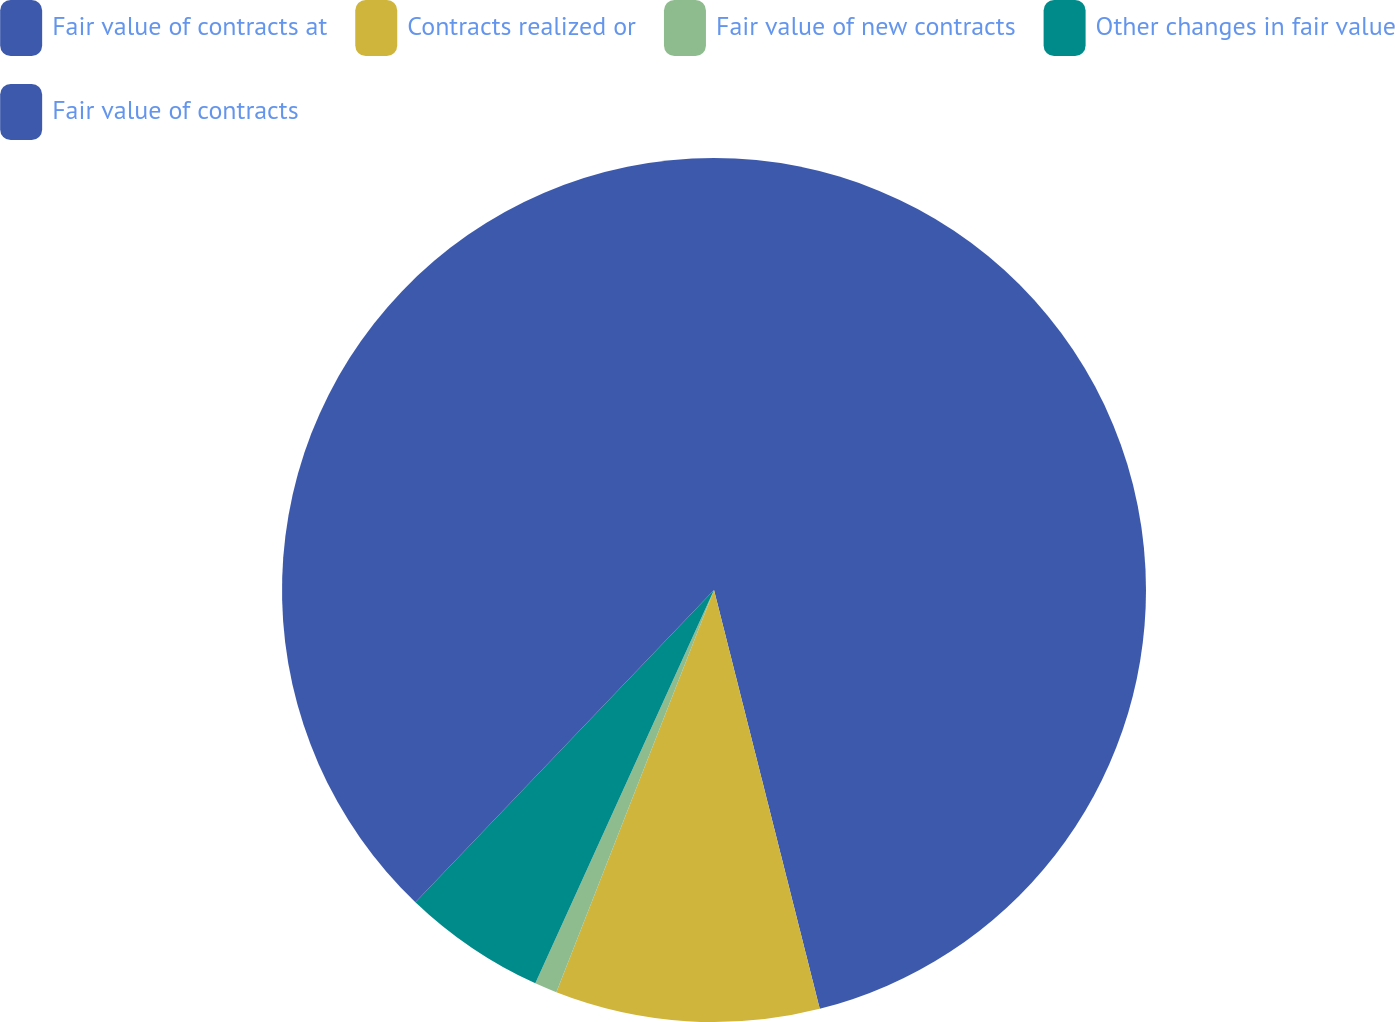Convert chart. <chart><loc_0><loc_0><loc_500><loc_500><pie_chart><fcel>Fair value of contracts at<fcel>Contracts realized or<fcel>Fair value of new contracts<fcel>Other changes in fair value<fcel>Fair value of contracts<nl><fcel>46.06%<fcel>9.88%<fcel>0.84%<fcel>5.36%<fcel>37.85%<nl></chart> 